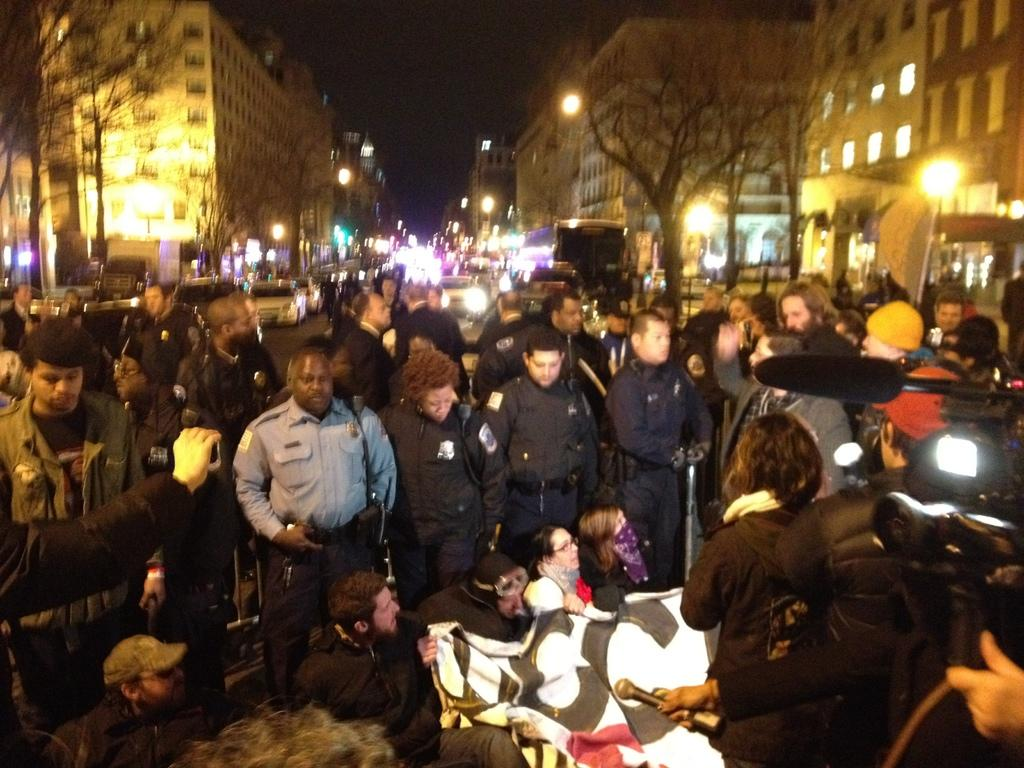How many people are in the image? There is a group of people in the image, but the exact number is not specified. What type of items can be seen in the image? Cloth items, a camera, a microphone, street lamps, trees, and buildings are visible in the image. What is the lighting condition in the image? The image appears to be slightly dark. What is visible at the top of the image? The sky is visible at the top of the image. What type of soap is being used for punishment in the image? There is no soap or punishment present in the image. What is the comparison between the cloth items and the street lamps in the image? There is no comparison being made between the cloth items and the street lamps in the image. 